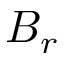<formula> <loc_0><loc_0><loc_500><loc_500>B _ { r }</formula> 